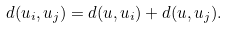<formula> <loc_0><loc_0><loc_500><loc_500>d ( u _ { i } , u _ { j } ) = d ( u , u _ { i } ) + d ( u , u _ { j } ) .</formula> 